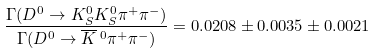<formula> <loc_0><loc_0><loc_500><loc_500>\frac { \Gamma ( D ^ { 0 } \rightarrow K ^ { 0 } _ { S } K ^ { 0 } _ { S } \pi ^ { + } \pi ^ { - } ) } { \Gamma ( D ^ { 0 } \rightarrow { \overline { K } \, ^ { 0 } } \pi ^ { + } \pi ^ { - } ) } = 0 . 0 2 0 8 \pm 0 . 0 0 3 5 \pm 0 . 0 0 2 1</formula> 